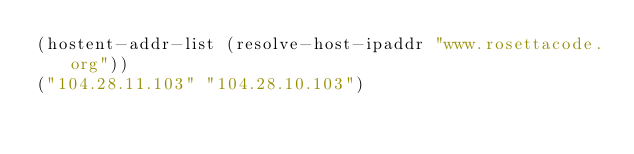Convert code to text. <code><loc_0><loc_0><loc_500><loc_500><_Lisp_>(hostent-addr-list (resolve-host-ipaddr "www.rosettacode.org"))
("104.28.11.103" "104.28.10.103")
</code> 